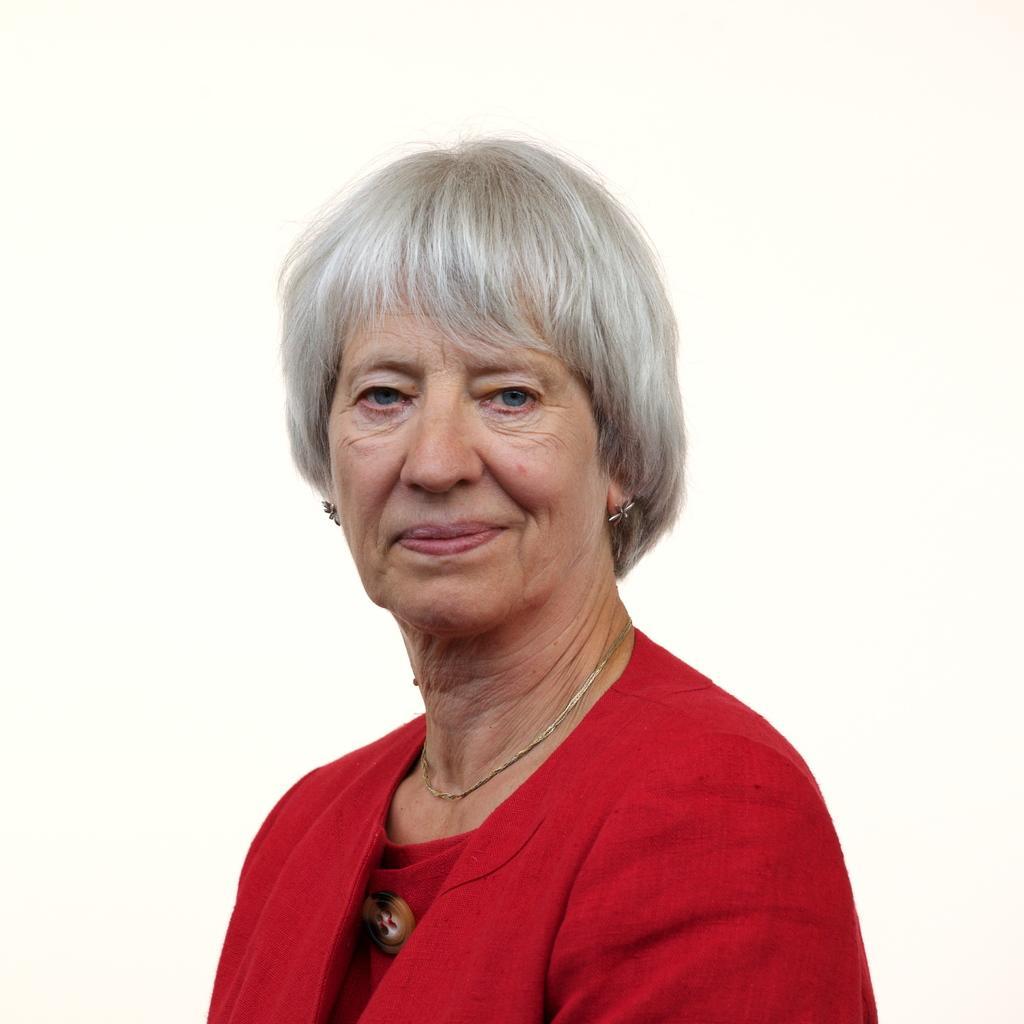Could you give a brief overview of what you see in this image? In the foreground I can see a woman. In the background I can see a white color. This image is taken may be in a room. 